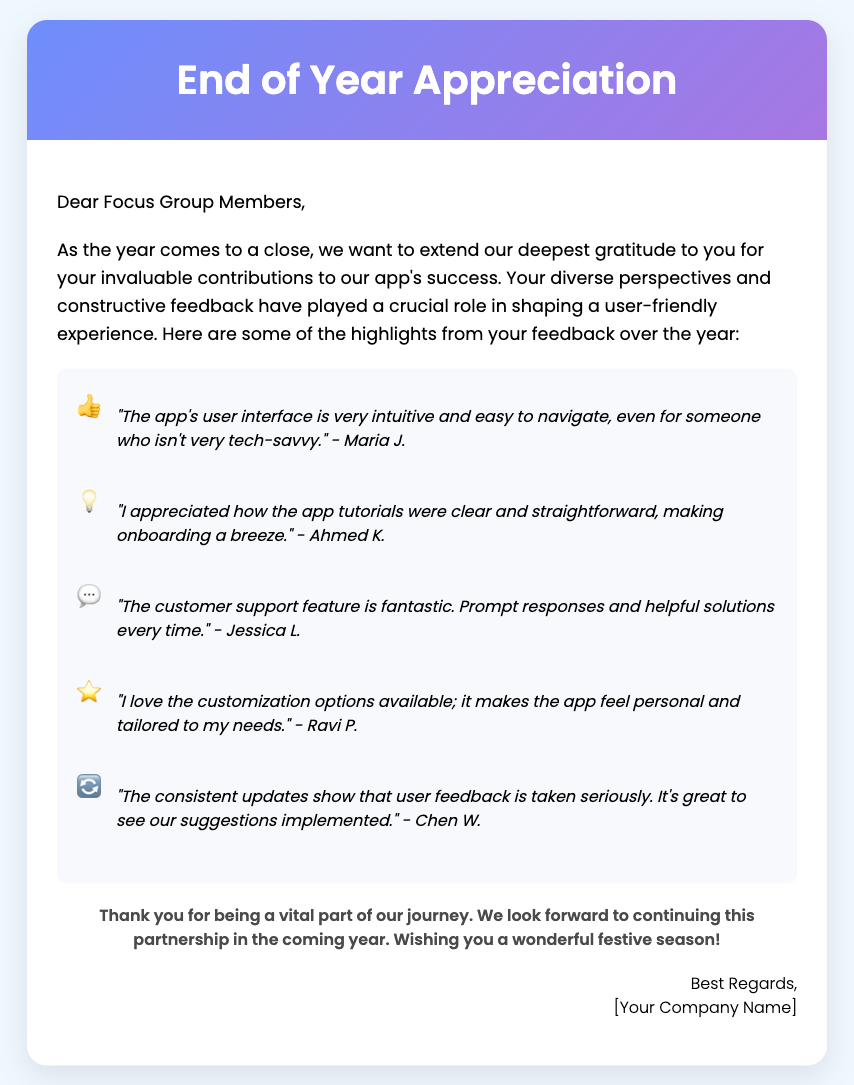What is the title of the card? The title of the card is prominently displayed in the card header section.
Answer: End of Year Appreciation Who is the card addressed to? The card includes a greeting that specifies its intended recipients.
Answer: Focus Group Members How many feedback highlights are presented in the card? There are several distinct feedback items mentioned in the feedback section of the card.
Answer: Five Which feedback quote mentions customer support? One of the quotes specifically highlights experiences with customer support.
Answer: "The customer support feature is fantastic. Prompt responses and helpful solutions every time." - Jessica L What is the closing message of the card? The closing paragraph provides sentiments towards the focus group members and wishes them well.
Answer: Thank you for being a vital part of our journey. We look forward to continuing this partnership in the coming year. Wishing you a wonderful festive season! What illustration theme is featured in the card's design? The card's visuals are described with a specific thematic inspiration in the prompt.
Answer: Festive, tech-inspired illustrations 